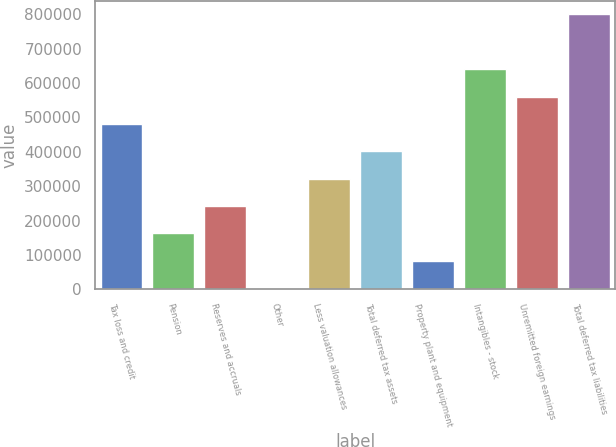<chart> <loc_0><loc_0><loc_500><loc_500><bar_chart><fcel>Tax loss and credit<fcel>Pension<fcel>Reserves and accruals<fcel>Other<fcel>Less valuation allowances<fcel>Total deferred tax assets<fcel>Property plant and equipment<fcel>Intangibles - stock<fcel>Unremitted foreign earnings<fcel>Total deferred tax liabilities<nl><fcel>481007<fcel>162748<fcel>242313<fcel>3619<fcel>321878<fcel>401442<fcel>83183.7<fcel>640137<fcel>560572<fcel>799266<nl></chart> 